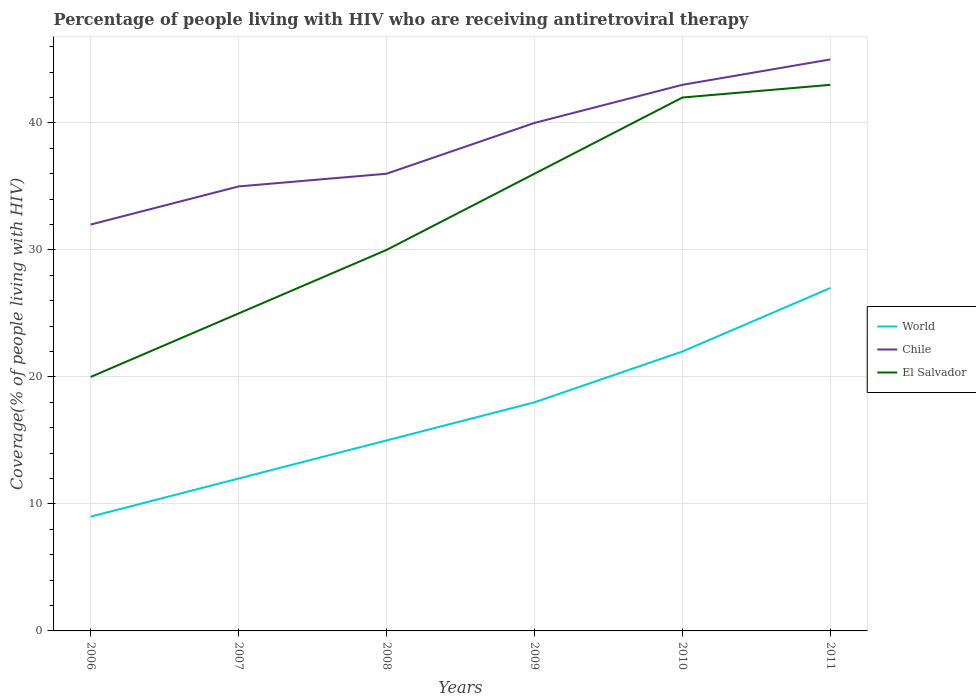How many different coloured lines are there?
Offer a terse response. 3. Across all years, what is the maximum percentage of the HIV infected people who are receiving antiretroviral therapy in World?
Your response must be concise. 9. What is the total percentage of the HIV infected people who are receiving antiretroviral therapy in El Salvador in the graph?
Ensure brevity in your answer.  -12. What is the difference between the highest and the second highest percentage of the HIV infected people who are receiving antiretroviral therapy in Chile?
Offer a very short reply. 13. What is the difference between the highest and the lowest percentage of the HIV infected people who are receiving antiretroviral therapy in El Salvador?
Provide a short and direct response. 3. Is the percentage of the HIV infected people who are receiving antiretroviral therapy in Chile strictly greater than the percentage of the HIV infected people who are receiving antiretroviral therapy in World over the years?
Ensure brevity in your answer.  No. How many lines are there?
Give a very brief answer. 3. How many years are there in the graph?
Provide a short and direct response. 6. Where does the legend appear in the graph?
Offer a terse response. Center right. How many legend labels are there?
Offer a terse response. 3. What is the title of the graph?
Ensure brevity in your answer.  Percentage of people living with HIV who are receiving antiretroviral therapy. What is the label or title of the Y-axis?
Provide a succinct answer. Coverage(% of people living with HIV). What is the Coverage(% of people living with HIV) of El Salvador in 2006?
Offer a terse response. 20. What is the Coverage(% of people living with HIV) of El Salvador in 2007?
Give a very brief answer. 25. What is the Coverage(% of people living with HIV) of El Salvador in 2008?
Your response must be concise. 30. What is the Coverage(% of people living with HIV) of World in 2009?
Give a very brief answer. 18. What is the Coverage(% of people living with HIV) in Chile in 2009?
Provide a short and direct response. 40. What is the Coverage(% of people living with HIV) in El Salvador in 2009?
Your answer should be compact. 36. What is the Coverage(% of people living with HIV) of Chile in 2010?
Your answer should be compact. 43. What is the Coverage(% of people living with HIV) in El Salvador in 2010?
Your response must be concise. 42. What is the Coverage(% of people living with HIV) of World in 2011?
Your answer should be very brief. 27. What is the Coverage(% of people living with HIV) of Chile in 2011?
Provide a succinct answer. 45. What is the Coverage(% of people living with HIV) in El Salvador in 2011?
Keep it short and to the point. 43. Across all years, what is the maximum Coverage(% of people living with HIV) of El Salvador?
Ensure brevity in your answer.  43. Across all years, what is the minimum Coverage(% of people living with HIV) of World?
Offer a terse response. 9. Across all years, what is the minimum Coverage(% of people living with HIV) of Chile?
Make the answer very short. 32. Across all years, what is the minimum Coverage(% of people living with HIV) in El Salvador?
Ensure brevity in your answer.  20. What is the total Coverage(% of people living with HIV) in World in the graph?
Your answer should be compact. 103. What is the total Coverage(% of people living with HIV) in Chile in the graph?
Offer a terse response. 231. What is the total Coverage(% of people living with HIV) of El Salvador in the graph?
Offer a terse response. 196. What is the difference between the Coverage(% of people living with HIV) in Chile in 2006 and that in 2008?
Your answer should be very brief. -4. What is the difference between the Coverage(% of people living with HIV) in Chile in 2006 and that in 2009?
Your answer should be very brief. -8. What is the difference between the Coverage(% of people living with HIV) of El Salvador in 2006 and that in 2009?
Your response must be concise. -16. What is the difference between the Coverage(% of people living with HIV) of Chile in 2006 and that in 2010?
Provide a short and direct response. -11. What is the difference between the Coverage(% of people living with HIV) in El Salvador in 2006 and that in 2010?
Your answer should be very brief. -22. What is the difference between the Coverage(% of people living with HIV) in Chile in 2006 and that in 2011?
Provide a short and direct response. -13. What is the difference between the Coverage(% of people living with HIV) in El Salvador in 2006 and that in 2011?
Offer a very short reply. -23. What is the difference between the Coverage(% of people living with HIV) in World in 2007 and that in 2008?
Your response must be concise. -3. What is the difference between the Coverage(% of people living with HIV) of El Salvador in 2007 and that in 2008?
Keep it short and to the point. -5. What is the difference between the Coverage(% of people living with HIV) of World in 2007 and that in 2009?
Offer a terse response. -6. What is the difference between the Coverage(% of people living with HIV) in World in 2007 and that in 2011?
Ensure brevity in your answer.  -15. What is the difference between the Coverage(% of people living with HIV) in Chile in 2007 and that in 2011?
Offer a very short reply. -10. What is the difference between the Coverage(% of people living with HIV) of El Salvador in 2007 and that in 2011?
Give a very brief answer. -18. What is the difference between the Coverage(% of people living with HIV) of World in 2008 and that in 2009?
Offer a terse response. -3. What is the difference between the Coverage(% of people living with HIV) in Chile in 2008 and that in 2009?
Offer a very short reply. -4. What is the difference between the Coverage(% of people living with HIV) in El Salvador in 2008 and that in 2009?
Keep it short and to the point. -6. What is the difference between the Coverage(% of people living with HIV) in Chile in 2008 and that in 2010?
Offer a very short reply. -7. What is the difference between the Coverage(% of people living with HIV) of El Salvador in 2008 and that in 2010?
Your answer should be very brief. -12. What is the difference between the Coverage(% of people living with HIV) of Chile in 2008 and that in 2011?
Give a very brief answer. -9. What is the difference between the Coverage(% of people living with HIV) in World in 2009 and that in 2010?
Your answer should be very brief. -4. What is the difference between the Coverage(% of people living with HIV) of Chile in 2009 and that in 2010?
Provide a succinct answer. -3. What is the difference between the Coverage(% of people living with HIV) of El Salvador in 2009 and that in 2010?
Your answer should be very brief. -6. What is the difference between the Coverage(% of people living with HIV) in World in 2009 and that in 2011?
Your answer should be compact. -9. What is the difference between the Coverage(% of people living with HIV) in El Salvador in 2009 and that in 2011?
Your response must be concise. -7. What is the difference between the Coverage(% of people living with HIV) of World in 2010 and that in 2011?
Keep it short and to the point. -5. What is the difference between the Coverage(% of people living with HIV) of Chile in 2010 and that in 2011?
Make the answer very short. -2. What is the difference between the Coverage(% of people living with HIV) in El Salvador in 2010 and that in 2011?
Keep it short and to the point. -1. What is the difference between the Coverage(% of people living with HIV) of World in 2006 and the Coverage(% of people living with HIV) of Chile in 2007?
Make the answer very short. -26. What is the difference between the Coverage(% of people living with HIV) in Chile in 2006 and the Coverage(% of people living with HIV) in El Salvador in 2007?
Offer a terse response. 7. What is the difference between the Coverage(% of people living with HIV) of Chile in 2006 and the Coverage(% of people living with HIV) of El Salvador in 2008?
Ensure brevity in your answer.  2. What is the difference between the Coverage(% of people living with HIV) of World in 2006 and the Coverage(% of people living with HIV) of Chile in 2009?
Provide a short and direct response. -31. What is the difference between the Coverage(% of people living with HIV) of World in 2006 and the Coverage(% of people living with HIV) of El Salvador in 2009?
Keep it short and to the point. -27. What is the difference between the Coverage(% of people living with HIV) in Chile in 2006 and the Coverage(% of people living with HIV) in El Salvador in 2009?
Make the answer very short. -4. What is the difference between the Coverage(% of people living with HIV) of World in 2006 and the Coverage(% of people living with HIV) of Chile in 2010?
Your answer should be compact. -34. What is the difference between the Coverage(% of people living with HIV) in World in 2006 and the Coverage(% of people living with HIV) in El Salvador in 2010?
Keep it short and to the point. -33. What is the difference between the Coverage(% of people living with HIV) of Chile in 2006 and the Coverage(% of people living with HIV) of El Salvador in 2010?
Provide a short and direct response. -10. What is the difference between the Coverage(% of people living with HIV) in World in 2006 and the Coverage(% of people living with HIV) in Chile in 2011?
Offer a terse response. -36. What is the difference between the Coverage(% of people living with HIV) in World in 2006 and the Coverage(% of people living with HIV) in El Salvador in 2011?
Ensure brevity in your answer.  -34. What is the difference between the Coverage(% of people living with HIV) in Chile in 2006 and the Coverage(% of people living with HIV) in El Salvador in 2011?
Make the answer very short. -11. What is the difference between the Coverage(% of people living with HIV) of World in 2007 and the Coverage(% of people living with HIV) of Chile in 2009?
Provide a succinct answer. -28. What is the difference between the Coverage(% of people living with HIV) of World in 2007 and the Coverage(% of people living with HIV) of El Salvador in 2009?
Your response must be concise. -24. What is the difference between the Coverage(% of people living with HIV) in World in 2007 and the Coverage(% of people living with HIV) in Chile in 2010?
Your answer should be compact. -31. What is the difference between the Coverage(% of people living with HIV) in World in 2007 and the Coverage(% of people living with HIV) in El Salvador in 2010?
Keep it short and to the point. -30. What is the difference between the Coverage(% of people living with HIV) in World in 2007 and the Coverage(% of people living with HIV) in Chile in 2011?
Your answer should be very brief. -33. What is the difference between the Coverage(% of people living with HIV) in World in 2007 and the Coverage(% of people living with HIV) in El Salvador in 2011?
Your answer should be compact. -31. What is the difference between the Coverage(% of people living with HIV) of World in 2008 and the Coverage(% of people living with HIV) of El Salvador in 2009?
Provide a succinct answer. -21. What is the difference between the Coverage(% of people living with HIV) in World in 2008 and the Coverage(% of people living with HIV) in Chile in 2010?
Make the answer very short. -28. What is the difference between the Coverage(% of people living with HIV) in Chile in 2008 and the Coverage(% of people living with HIV) in El Salvador in 2010?
Your answer should be very brief. -6. What is the difference between the Coverage(% of people living with HIV) of World in 2008 and the Coverage(% of people living with HIV) of Chile in 2011?
Provide a succinct answer. -30. What is the difference between the Coverage(% of people living with HIV) of World in 2008 and the Coverage(% of people living with HIV) of El Salvador in 2011?
Your answer should be very brief. -28. What is the difference between the Coverage(% of people living with HIV) in Chile in 2008 and the Coverage(% of people living with HIV) in El Salvador in 2011?
Offer a very short reply. -7. What is the difference between the Coverage(% of people living with HIV) of World in 2009 and the Coverage(% of people living with HIV) of Chile in 2011?
Make the answer very short. -27. What is the difference between the Coverage(% of people living with HIV) of World in 2009 and the Coverage(% of people living with HIV) of El Salvador in 2011?
Provide a short and direct response. -25. What is the difference between the Coverage(% of people living with HIV) of Chile in 2009 and the Coverage(% of people living with HIV) of El Salvador in 2011?
Give a very brief answer. -3. What is the difference between the Coverage(% of people living with HIV) in World in 2010 and the Coverage(% of people living with HIV) in Chile in 2011?
Provide a short and direct response. -23. What is the difference between the Coverage(% of people living with HIV) of World in 2010 and the Coverage(% of people living with HIV) of El Salvador in 2011?
Ensure brevity in your answer.  -21. What is the average Coverage(% of people living with HIV) in World per year?
Make the answer very short. 17.17. What is the average Coverage(% of people living with HIV) in Chile per year?
Your response must be concise. 38.5. What is the average Coverage(% of people living with HIV) in El Salvador per year?
Your response must be concise. 32.67. In the year 2006, what is the difference between the Coverage(% of people living with HIV) in Chile and Coverage(% of people living with HIV) in El Salvador?
Ensure brevity in your answer.  12. In the year 2007, what is the difference between the Coverage(% of people living with HIV) in World and Coverage(% of people living with HIV) in Chile?
Your answer should be compact. -23. In the year 2007, what is the difference between the Coverage(% of people living with HIV) in World and Coverage(% of people living with HIV) in El Salvador?
Give a very brief answer. -13. In the year 2007, what is the difference between the Coverage(% of people living with HIV) of Chile and Coverage(% of people living with HIV) of El Salvador?
Your answer should be compact. 10. In the year 2008, what is the difference between the Coverage(% of people living with HIV) of World and Coverage(% of people living with HIV) of Chile?
Offer a terse response. -21. In the year 2008, what is the difference between the Coverage(% of people living with HIV) in World and Coverage(% of people living with HIV) in El Salvador?
Give a very brief answer. -15. In the year 2009, what is the difference between the Coverage(% of people living with HIV) in World and Coverage(% of people living with HIV) in Chile?
Give a very brief answer. -22. In the year 2009, what is the difference between the Coverage(% of people living with HIV) of World and Coverage(% of people living with HIV) of El Salvador?
Keep it short and to the point. -18. In the year 2009, what is the difference between the Coverage(% of people living with HIV) in Chile and Coverage(% of people living with HIV) in El Salvador?
Offer a very short reply. 4. In the year 2010, what is the difference between the Coverage(% of people living with HIV) in World and Coverage(% of people living with HIV) in Chile?
Ensure brevity in your answer.  -21. In the year 2010, what is the difference between the Coverage(% of people living with HIV) in World and Coverage(% of people living with HIV) in El Salvador?
Make the answer very short. -20. What is the ratio of the Coverage(% of people living with HIV) in Chile in 2006 to that in 2007?
Offer a very short reply. 0.91. What is the ratio of the Coverage(% of people living with HIV) in World in 2006 to that in 2008?
Ensure brevity in your answer.  0.6. What is the ratio of the Coverage(% of people living with HIV) in Chile in 2006 to that in 2008?
Offer a very short reply. 0.89. What is the ratio of the Coverage(% of people living with HIV) in El Salvador in 2006 to that in 2009?
Offer a very short reply. 0.56. What is the ratio of the Coverage(% of people living with HIV) of World in 2006 to that in 2010?
Ensure brevity in your answer.  0.41. What is the ratio of the Coverage(% of people living with HIV) in Chile in 2006 to that in 2010?
Your answer should be compact. 0.74. What is the ratio of the Coverage(% of people living with HIV) of El Salvador in 2006 to that in 2010?
Your response must be concise. 0.48. What is the ratio of the Coverage(% of people living with HIV) in World in 2006 to that in 2011?
Keep it short and to the point. 0.33. What is the ratio of the Coverage(% of people living with HIV) in Chile in 2006 to that in 2011?
Provide a succinct answer. 0.71. What is the ratio of the Coverage(% of people living with HIV) in El Salvador in 2006 to that in 2011?
Offer a terse response. 0.47. What is the ratio of the Coverage(% of people living with HIV) in World in 2007 to that in 2008?
Your response must be concise. 0.8. What is the ratio of the Coverage(% of people living with HIV) of Chile in 2007 to that in 2008?
Ensure brevity in your answer.  0.97. What is the ratio of the Coverage(% of people living with HIV) in El Salvador in 2007 to that in 2008?
Ensure brevity in your answer.  0.83. What is the ratio of the Coverage(% of people living with HIV) in World in 2007 to that in 2009?
Make the answer very short. 0.67. What is the ratio of the Coverage(% of people living with HIV) of Chile in 2007 to that in 2009?
Your answer should be very brief. 0.88. What is the ratio of the Coverage(% of people living with HIV) of El Salvador in 2007 to that in 2009?
Your answer should be very brief. 0.69. What is the ratio of the Coverage(% of people living with HIV) of World in 2007 to that in 2010?
Make the answer very short. 0.55. What is the ratio of the Coverage(% of people living with HIV) in Chile in 2007 to that in 2010?
Your response must be concise. 0.81. What is the ratio of the Coverage(% of people living with HIV) in El Salvador in 2007 to that in 2010?
Ensure brevity in your answer.  0.6. What is the ratio of the Coverage(% of people living with HIV) in World in 2007 to that in 2011?
Offer a terse response. 0.44. What is the ratio of the Coverage(% of people living with HIV) in El Salvador in 2007 to that in 2011?
Give a very brief answer. 0.58. What is the ratio of the Coverage(% of people living with HIV) in World in 2008 to that in 2009?
Ensure brevity in your answer.  0.83. What is the ratio of the Coverage(% of people living with HIV) of El Salvador in 2008 to that in 2009?
Provide a succinct answer. 0.83. What is the ratio of the Coverage(% of people living with HIV) in World in 2008 to that in 2010?
Your answer should be compact. 0.68. What is the ratio of the Coverage(% of people living with HIV) in Chile in 2008 to that in 2010?
Keep it short and to the point. 0.84. What is the ratio of the Coverage(% of people living with HIV) in El Salvador in 2008 to that in 2010?
Make the answer very short. 0.71. What is the ratio of the Coverage(% of people living with HIV) of World in 2008 to that in 2011?
Give a very brief answer. 0.56. What is the ratio of the Coverage(% of people living with HIV) of El Salvador in 2008 to that in 2011?
Ensure brevity in your answer.  0.7. What is the ratio of the Coverage(% of people living with HIV) in World in 2009 to that in 2010?
Give a very brief answer. 0.82. What is the ratio of the Coverage(% of people living with HIV) in Chile in 2009 to that in 2010?
Make the answer very short. 0.93. What is the ratio of the Coverage(% of people living with HIV) in El Salvador in 2009 to that in 2010?
Give a very brief answer. 0.86. What is the ratio of the Coverage(% of people living with HIV) of El Salvador in 2009 to that in 2011?
Make the answer very short. 0.84. What is the ratio of the Coverage(% of people living with HIV) of World in 2010 to that in 2011?
Offer a terse response. 0.81. What is the ratio of the Coverage(% of people living with HIV) in Chile in 2010 to that in 2011?
Offer a very short reply. 0.96. What is the ratio of the Coverage(% of people living with HIV) in El Salvador in 2010 to that in 2011?
Your answer should be compact. 0.98. What is the difference between the highest and the second highest Coverage(% of people living with HIV) of Chile?
Ensure brevity in your answer.  2. What is the difference between the highest and the second highest Coverage(% of people living with HIV) in El Salvador?
Offer a terse response. 1. What is the difference between the highest and the lowest Coverage(% of people living with HIV) of El Salvador?
Your response must be concise. 23. 